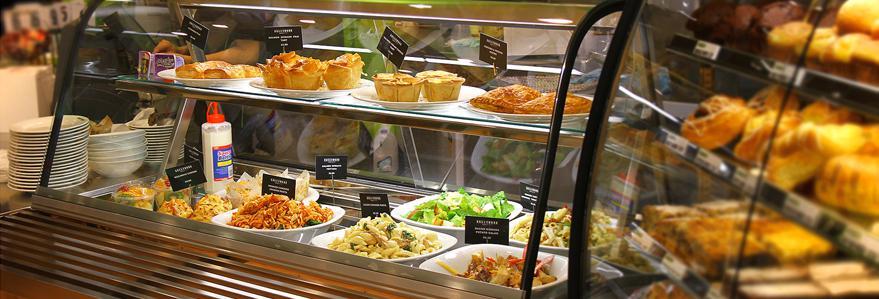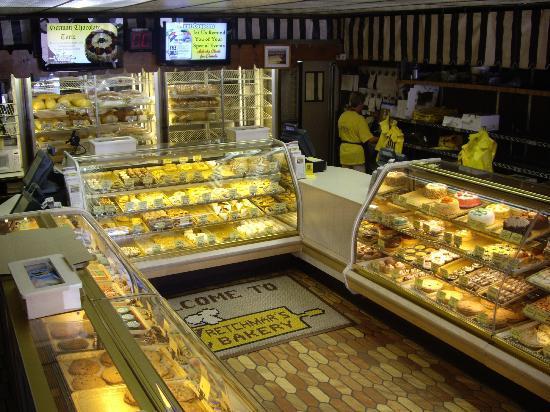The first image is the image on the left, the second image is the image on the right. Analyze the images presented: Is the assertion "There are visible workers behind the the bakers cookie and brownie display case." valid? Answer yes or no. Yes. The first image is the image on the left, the second image is the image on the right. Given the left and right images, does the statement "Only one person is visible in the image." hold true? Answer yes or no. No. 